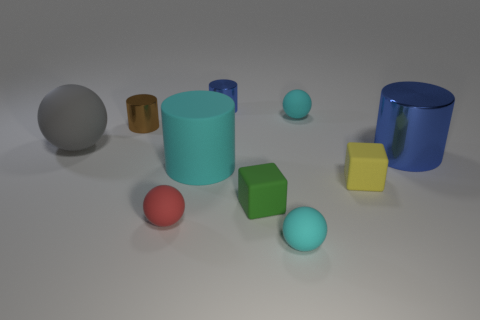What is the material of the cube on the right side of the tiny matte object that is behind the small shiny cylinder that is in front of the small blue object?
Your answer should be compact. Rubber. There is a tiny matte cube to the right of the cyan matte sphere that is in front of the green rubber thing; what is its color?
Provide a short and direct response. Yellow. What number of big things are cyan objects or brown objects?
Make the answer very short. 1. How many cyan balls have the same material as the gray ball?
Your answer should be compact. 2. What size is the block that is on the left side of the yellow block?
Offer a very short reply. Small. There is a cyan object that is behind the large thing to the left of the large cyan cylinder; what shape is it?
Ensure brevity in your answer.  Sphere. There is a cyan ball in front of the tiny red object that is to the right of the gray matte thing; how many shiny objects are behind it?
Make the answer very short. 3. Is the number of cyan spheres that are in front of the big blue metal cylinder less than the number of tiny yellow rubber cubes?
Make the answer very short. No. What shape is the green thing to the left of the large blue cylinder?
Your response must be concise. Cube. What shape is the blue shiny thing that is in front of the gray ball in front of the cyan rubber ball behind the large rubber cylinder?
Provide a short and direct response. Cylinder. 